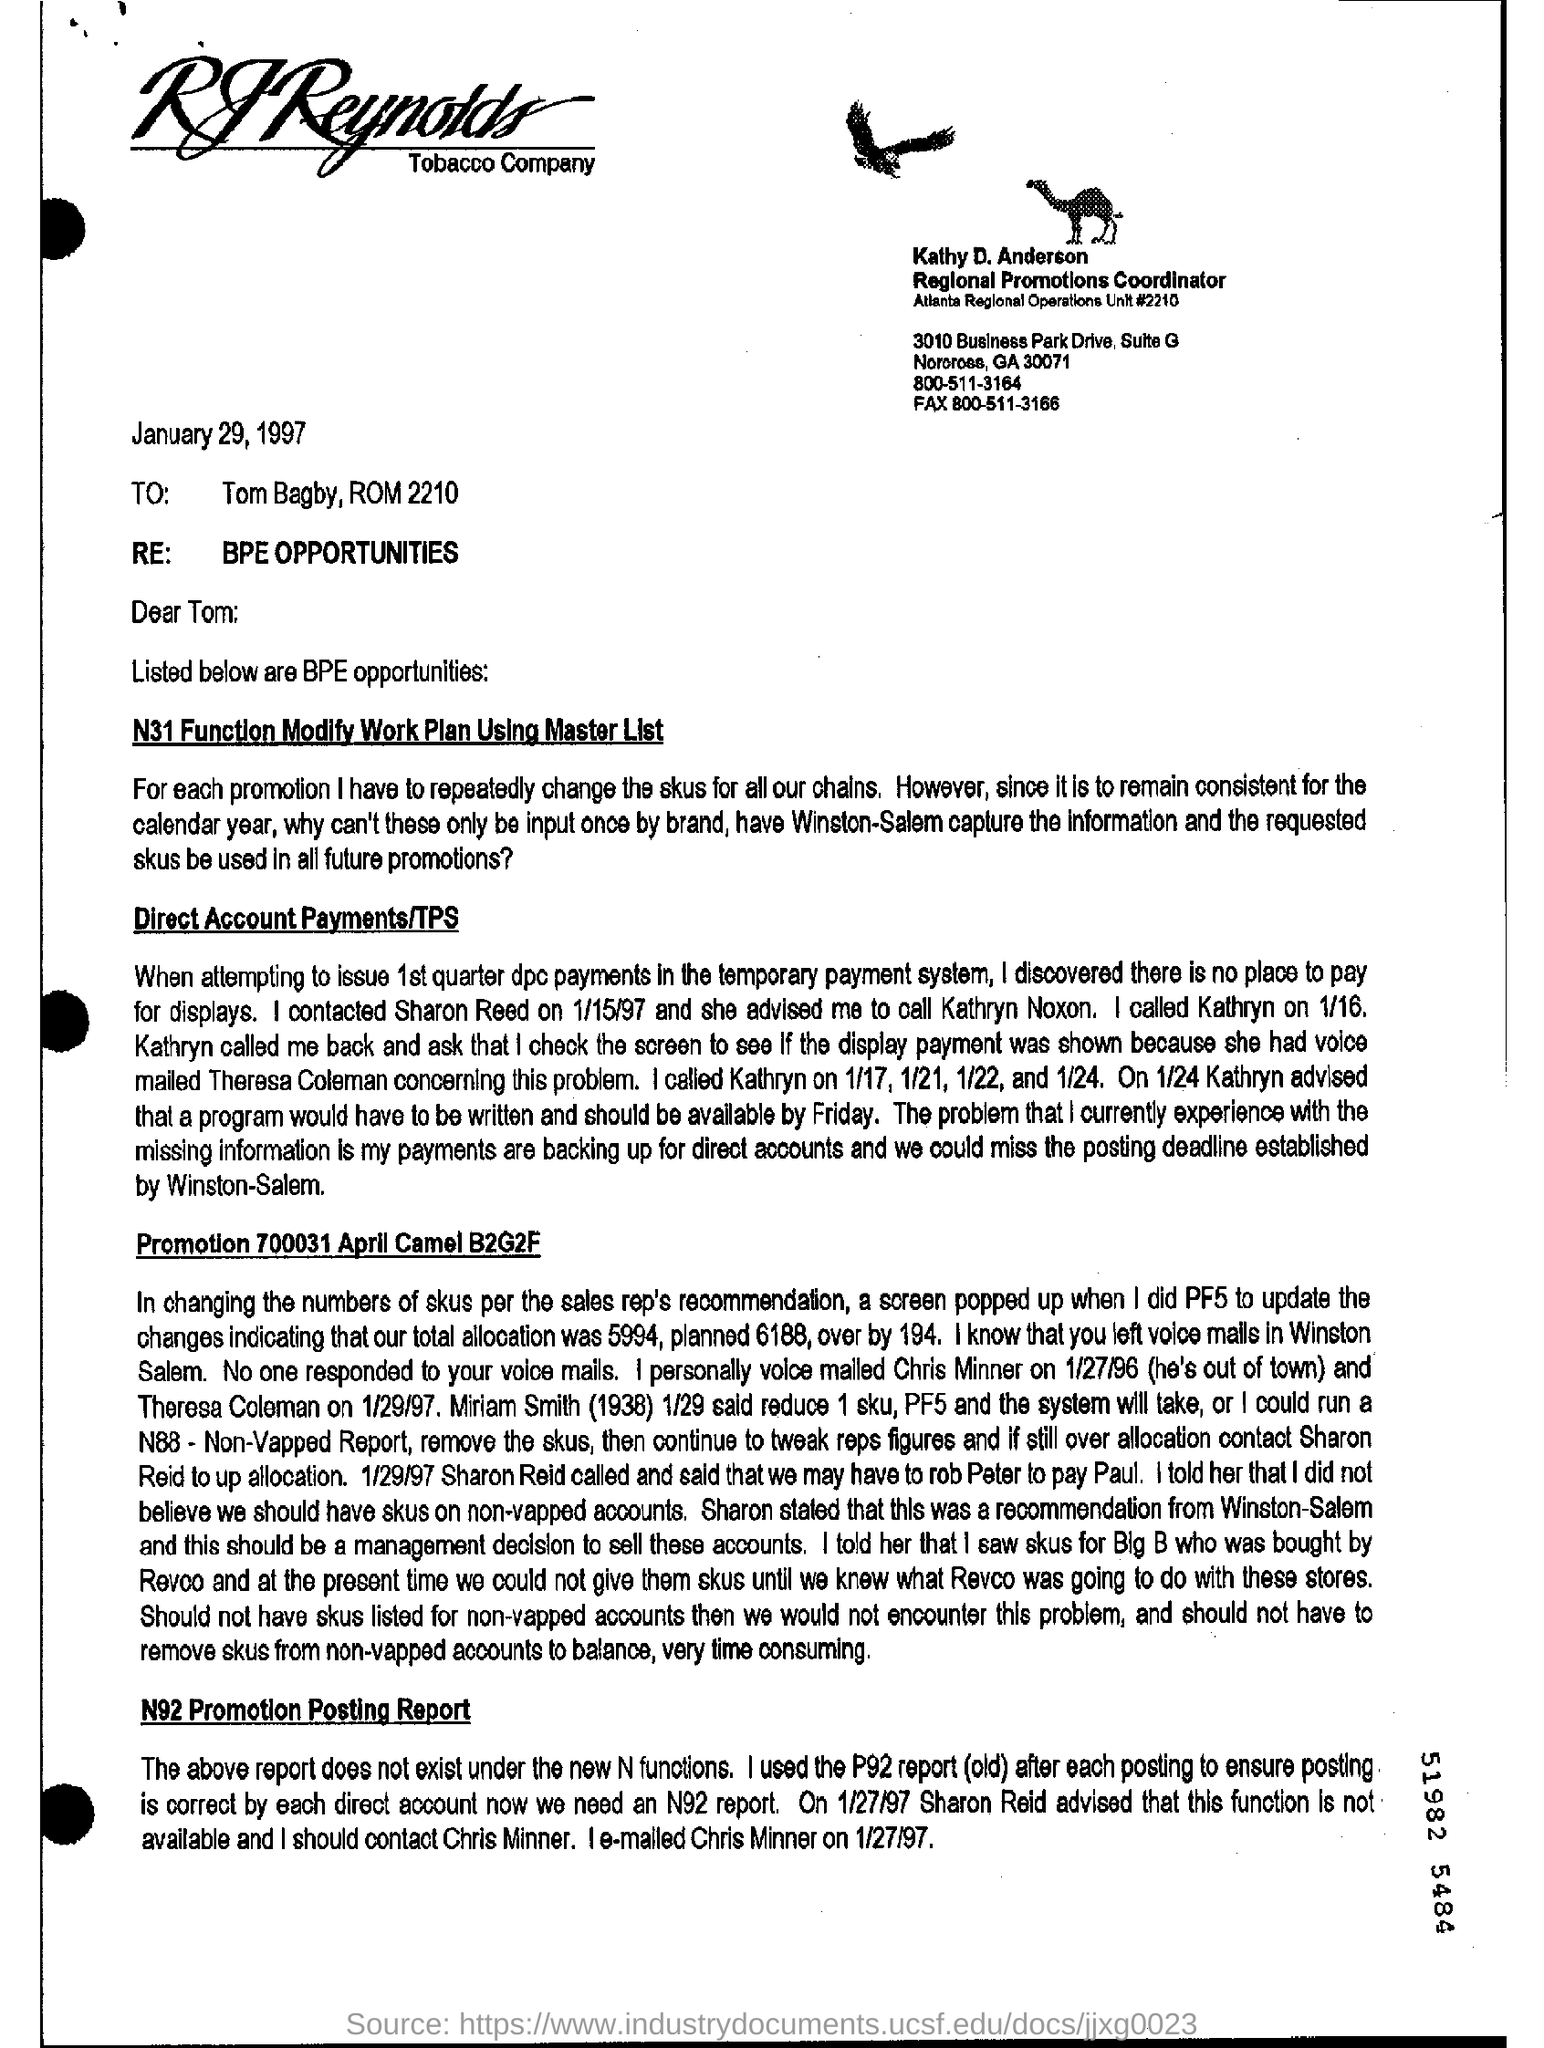What is the date mentioned?
Provide a short and direct response. January 29, 1997. To whom is this document addressed?
Your answer should be compact. Tom Bagby, ROM 2210. Using which list is the N31 Function Modify Work Plan made?
Provide a succinct answer. Master list. 